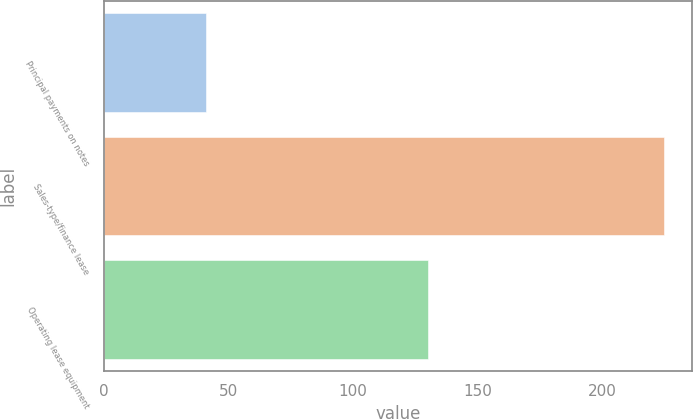<chart> <loc_0><loc_0><loc_500><loc_500><bar_chart><fcel>Principal payments on notes<fcel>Sales-type/finance lease<fcel>Operating lease equipment<nl><fcel>41<fcel>225<fcel>130<nl></chart> 